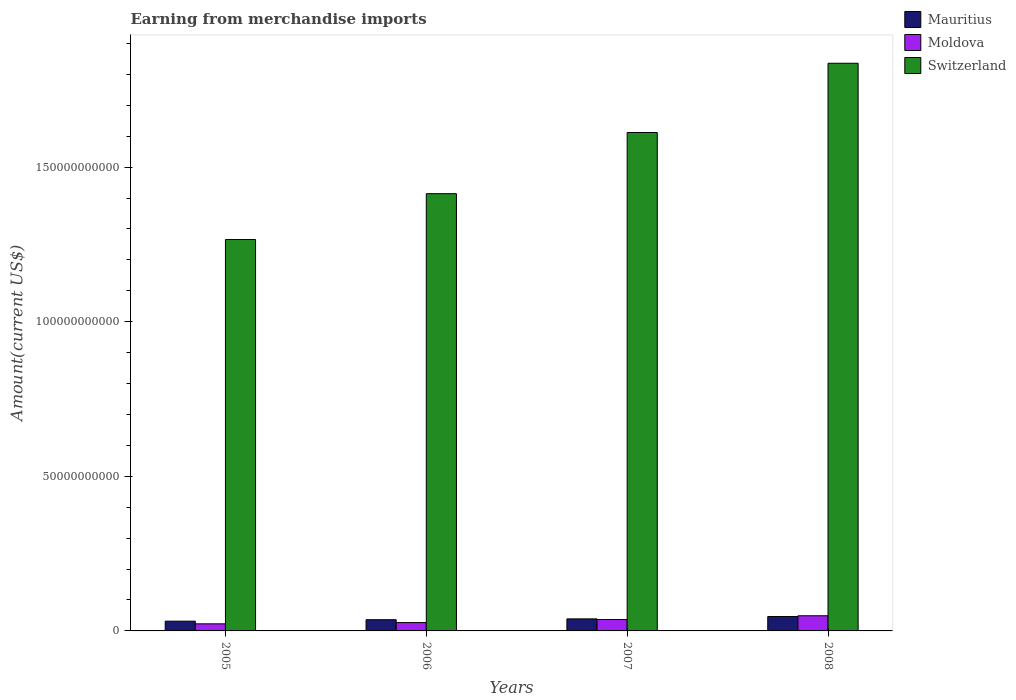How many different coloured bars are there?
Your response must be concise. 3. How many groups of bars are there?
Make the answer very short. 4. Are the number of bars per tick equal to the number of legend labels?
Offer a very short reply. Yes. How many bars are there on the 2nd tick from the left?
Provide a succinct answer. 3. How many bars are there on the 4th tick from the right?
Your answer should be very brief. 3. In how many cases, is the number of bars for a given year not equal to the number of legend labels?
Your response must be concise. 0. What is the amount earned from merchandise imports in Switzerland in 2005?
Give a very brief answer. 1.27e+11. Across all years, what is the maximum amount earned from merchandise imports in Moldova?
Your answer should be very brief. 4.90e+09. Across all years, what is the minimum amount earned from merchandise imports in Moldova?
Your answer should be compact. 2.29e+09. In which year was the amount earned from merchandise imports in Moldova minimum?
Your answer should be compact. 2005. What is the total amount earned from merchandise imports in Mauritius in the graph?
Your answer should be compact. 1.53e+1. What is the difference between the amount earned from merchandise imports in Mauritius in 2005 and that in 2006?
Your answer should be very brief. -4.70e+08. What is the difference between the amount earned from merchandise imports in Mauritius in 2008 and the amount earned from merchandise imports in Moldova in 2006?
Your answer should be compact. 1.96e+09. What is the average amount earned from merchandise imports in Mauritius per year?
Keep it short and to the point. 3.83e+09. In the year 2007, what is the difference between the amount earned from merchandise imports in Mauritius and amount earned from merchandise imports in Switzerland?
Ensure brevity in your answer.  -1.57e+11. In how many years, is the amount earned from merchandise imports in Switzerland greater than 170000000000 US$?
Offer a terse response. 1. What is the ratio of the amount earned from merchandise imports in Switzerland in 2006 to that in 2008?
Keep it short and to the point. 0.77. Is the amount earned from merchandise imports in Switzerland in 2005 less than that in 2008?
Make the answer very short. Yes. What is the difference between the highest and the second highest amount earned from merchandise imports in Switzerland?
Your answer should be very brief. 2.24e+1. What is the difference between the highest and the lowest amount earned from merchandise imports in Moldova?
Give a very brief answer. 2.61e+09. In how many years, is the amount earned from merchandise imports in Mauritius greater than the average amount earned from merchandise imports in Mauritius taken over all years?
Your response must be concise. 2. What does the 2nd bar from the left in 2007 represents?
Your response must be concise. Moldova. What does the 3rd bar from the right in 2007 represents?
Ensure brevity in your answer.  Mauritius. Are all the bars in the graph horizontal?
Provide a succinct answer. No. How many years are there in the graph?
Offer a very short reply. 4. What is the difference between two consecutive major ticks on the Y-axis?
Provide a succinct answer. 5.00e+1. Are the values on the major ticks of Y-axis written in scientific E-notation?
Offer a terse response. No. Does the graph contain any zero values?
Provide a short and direct response. No. What is the title of the graph?
Give a very brief answer. Earning from merchandise imports. Does "Eritrea" appear as one of the legend labels in the graph?
Your answer should be very brief. No. What is the label or title of the Y-axis?
Keep it short and to the point. Amount(current US$). What is the Amount(current US$) of Mauritius in 2005?
Ensure brevity in your answer.  3.16e+09. What is the Amount(current US$) in Moldova in 2005?
Your answer should be compact. 2.29e+09. What is the Amount(current US$) in Switzerland in 2005?
Your response must be concise. 1.27e+11. What is the Amount(current US$) in Mauritius in 2006?
Ensure brevity in your answer.  3.63e+09. What is the Amount(current US$) of Moldova in 2006?
Make the answer very short. 2.69e+09. What is the Amount(current US$) of Switzerland in 2006?
Give a very brief answer. 1.41e+11. What is the Amount(current US$) of Mauritius in 2007?
Give a very brief answer. 3.89e+09. What is the Amount(current US$) of Moldova in 2007?
Offer a very short reply. 3.69e+09. What is the Amount(current US$) in Switzerland in 2007?
Give a very brief answer. 1.61e+11. What is the Amount(current US$) in Mauritius in 2008?
Your response must be concise. 4.65e+09. What is the Amount(current US$) in Moldova in 2008?
Your response must be concise. 4.90e+09. What is the Amount(current US$) of Switzerland in 2008?
Ensure brevity in your answer.  1.84e+11. Across all years, what is the maximum Amount(current US$) in Mauritius?
Make the answer very short. 4.65e+09. Across all years, what is the maximum Amount(current US$) of Moldova?
Offer a very short reply. 4.90e+09. Across all years, what is the maximum Amount(current US$) of Switzerland?
Ensure brevity in your answer.  1.84e+11. Across all years, what is the minimum Amount(current US$) in Mauritius?
Offer a very short reply. 3.16e+09. Across all years, what is the minimum Amount(current US$) of Moldova?
Your answer should be compact. 2.29e+09. Across all years, what is the minimum Amount(current US$) of Switzerland?
Keep it short and to the point. 1.27e+11. What is the total Amount(current US$) of Mauritius in the graph?
Provide a succinct answer. 1.53e+1. What is the total Amount(current US$) of Moldova in the graph?
Keep it short and to the point. 1.36e+1. What is the total Amount(current US$) of Switzerland in the graph?
Provide a succinct answer. 6.13e+11. What is the difference between the Amount(current US$) in Mauritius in 2005 and that in 2006?
Provide a succinct answer. -4.70e+08. What is the difference between the Amount(current US$) in Moldova in 2005 and that in 2006?
Keep it short and to the point. -4.01e+08. What is the difference between the Amount(current US$) of Switzerland in 2005 and that in 2006?
Offer a terse response. -1.48e+1. What is the difference between the Amount(current US$) of Mauritius in 2005 and that in 2007?
Your answer should be compact. -7.37e+08. What is the difference between the Amount(current US$) in Moldova in 2005 and that in 2007?
Make the answer very short. -1.40e+09. What is the difference between the Amount(current US$) of Switzerland in 2005 and that in 2007?
Ensure brevity in your answer.  -3.46e+1. What is the difference between the Amount(current US$) in Mauritius in 2005 and that in 2008?
Make the answer very short. -1.49e+09. What is the difference between the Amount(current US$) of Moldova in 2005 and that in 2008?
Provide a succinct answer. -2.61e+09. What is the difference between the Amount(current US$) in Switzerland in 2005 and that in 2008?
Your answer should be compact. -5.70e+1. What is the difference between the Amount(current US$) in Mauritius in 2006 and that in 2007?
Give a very brief answer. -2.67e+08. What is the difference between the Amount(current US$) of Moldova in 2006 and that in 2007?
Ensure brevity in your answer.  -9.97e+08. What is the difference between the Amount(current US$) in Switzerland in 2006 and that in 2007?
Ensure brevity in your answer.  -1.98e+1. What is the difference between the Amount(current US$) of Mauritius in 2006 and that in 2008?
Ensure brevity in your answer.  -1.02e+09. What is the difference between the Amount(current US$) in Moldova in 2006 and that in 2008?
Offer a very short reply. -2.21e+09. What is the difference between the Amount(current US$) in Switzerland in 2006 and that in 2008?
Give a very brief answer. -4.22e+1. What is the difference between the Amount(current US$) of Mauritius in 2007 and that in 2008?
Ensure brevity in your answer.  -7.58e+08. What is the difference between the Amount(current US$) in Moldova in 2007 and that in 2008?
Give a very brief answer. -1.21e+09. What is the difference between the Amount(current US$) of Switzerland in 2007 and that in 2008?
Offer a very short reply. -2.24e+1. What is the difference between the Amount(current US$) of Mauritius in 2005 and the Amount(current US$) of Moldova in 2006?
Your answer should be very brief. 4.64e+08. What is the difference between the Amount(current US$) of Mauritius in 2005 and the Amount(current US$) of Switzerland in 2006?
Provide a succinct answer. -1.38e+11. What is the difference between the Amount(current US$) of Moldova in 2005 and the Amount(current US$) of Switzerland in 2006?
Your response must be concise. -1.39e+11. What is the difference between the Amount(current US$) in Mauritius in 2005 and the Amount(current US$) in Moldova in 2007?
Offer a very short reply. -5.33e+08. What is the difference between the Amount(current US$) in Mauritius in 2005 and the Amount(current US$) in Switzerland in 2007?
Make the answer very short. -1.58e+11. What is the difference between the Amount(current US$) in Moldova in 2005 and the Amount(current US$) in Switzerland in 2007?
Offer a terse response. -1.59e+11. What is the difference between the Amount(current US$) in Mauritius in 2005 and the Amount(current US$) in Moldova in 2008?
Provide a succinct answer. -1.74e+09. What is the difference between the Amount(current US$) of Mauritius in 2005 and the Amount(current US$) of Switzerland in 2008?
Your response must be concise. -1.80e+11. What is the difference between the Amount(current US$) of Moldova in 2005 and the Amount(current US$) of Switzerland in 2008?
Your answer should be compact. -1.81e+11. What is the difference between the Amount(current US$) in Mauritius in 2006 and the Amount(current US$) in Moldova in 2007?
Make the answer very short. -6.31e+07. What is the difference between the Amount(current US$) in Mauritius in 2006 and the Amount(current US$) in Switzerland in 2007?
Your answer should be compact. -1.58e+11. What is the difference between the Amount(current US$) in Moldova in 2006 and the Amount(current US$) in Switzerland in 2007?
Your response must be concise. -1.58e+11. What is the difference between the Amount(current US$) in Mauritius in 2006 and the Amount(current US$) in Moldova in 2008?
Keep it short and to the point. -1.27e+09. What is the difference between the Amount(current US$) in Mauritius in 2006 and the Amount(current US$) in Switzerland in 2008?
Make the answer very short. -1.80e+11. What is the difference between the Amount(current US$) of Moldova in 2006 and the Amount(current US$) of Switzerland in 2008?
Offer a terse response. -1.81e+11. What is the difference between the Amount(current US$) of Mauritius in 2007 and the Amount(current US$) of Moldova in 2008?
Keep it short and to the point. -1.01e+09. What is the difference between the Amount(current US$) of Mauritius in 2007 and the Amount(current US$) of Switzerland in 2008?
Keep it short and to the point. -1.80e+11. What is the difference between the Amount(current US$) of Moldova in 2007 and the Amount(current US$) of Switzerland in 2008?
Offer a terse response. -1.80e+11. What is the average Amount(current US$) in Mauritius per year?
Provide a succinct answer. 3.83e+09. What is the average Amount(current US$) in Moldova per year?
Your answer should be compact. 3.39e+09. What is the average Amount(current US$) in Switzerland per year?
Ensure brevity in your answer.  1.53e+11. In the year 2005, what is the difference between the Amount(current US$) in Mauritius and Amount(current US$) in Moldova?
Ensure brevity in your answer.  8.65e+08. In the year 2005, what is the difference between the Amount(current US$) of Mauritius and Amount(current US$) of Switzerland?
Make the answer very short. -1.23e+11. In the year 2005, what is the difference between the Amount(current US$) in Moldova and Amount(current US$) in Switzerland?
Your answer should be compact. -1.24e+11. In the year 2006, what is the difference between the Amount(current US$) of Mauritius and Amount(current US$) of Moldova?
Your response must be concise. 9.34e+08. In the year 2006, what is the difference between the Amount(current US$) of Mauritius and Amount(current US$) of Switzerland?
Keep it short and to the point. -1.38e+11. In the year 2006, what is the difference between the Amount(current US$) in Moldova and Amount(current US$) in Switzerland?
Give a very brief answer. -1.39e+11. In the year 2007, what is the difference between the Amount(current US$) of Mauritius and Amount(current US$) of Moldova?
Offer a terse response. 2.04e+08. In the year 2007, what is the difference between the Amount(current US$) in Mauritius and Amount(current US$) in Switzerland?
Give a very brief answer. -1.57e+11. In the year 2007, what is the difference between the Amount(current US$) of Moldova and Amount(current US$) of Switzerland?
Keep it short and to the point. -1.57e+11. In the year 2008, what is the difference between the Amount(current US$) of Mauritius and Amount(current US$) of Moldova?
Provide a succinct answer. -2.47e+08. In the year 2008, what is the difference between the Amount(current US$) in Mauritius and Amount(current US$) in Switzerland?
Your answer should be compact. -1.79e+11. In the year 2008, what is the difference between the Amount(current US$) of Moldova and Amount(current US$) of Switzerland?
Make the answer very short. -1.79e+11. What is the ratio of the Amount(current US$) in Mauritius in 2005 to that in 2006?
Offer a terse response. 0.87. What is the ratio of the Amount(current US$) of Moldova in 2005 to that in 2006?
Your answer should be compact. 0.85. What is the ratio of the Amount(current US$) in Switzerland in 2005 to that in 2006?
Make the answer very short. 0.9. What is the ratio of the Amount(current US$) of Mauritius in 2005 to that in 2007?
Your answer should be very brief. 0.81. What is the ratio of the Amount(current US$) of Moldova in 2005 to that in 2007?
Offer a terse response. 0.62. What is the ratio of the Amount(current US$) of Switzerland in 2005 to that in 2007?
Keep it short and to the point. 0.79. What is the ratio of the Amount(current US$) in Mauritius in 2005 to that in 2008?
Keep it short and to the point. 0.68. What is the ratio of the Amount(current US$) of Moldova in 2005 to that in 2008?
Your response must be concise. 0.47. What is the ratio of the Amount(current US$) of Switzerland in 2005 to that in 2008?
Provide a short and direct response. 0.69. What is the ratio of the Amount(current US$) of Mauritius in 2006 to that in 2007?
Provide a succinct answer. 0.93. What is the ratio of the Amount(current US$) in Moldova in 2006 to that in 2007?
Your response must be concise. 0.73. What is the ratio of the Amount(current US$) in Switzerland in 2006 to that in 2007?
Your response must be concise. 0.88. What is the ratio of the Amount(current US$) in Mauritius in 2006 to that in 2008?
Your response must be concise. 0.78. What is the ratio of the Amount(current US$) of Moldova in 2006 to that in 2008?
Offer a terse response. 0.55. What is the ratio of the Amount(current US$) in Switzerland in 2006 to that in 2008?
Give a very brief answer. 0.77. What is the ratio of the Amount(current US$) of Mauritius in 2007 to that in 2008?
Keep it short and to the point. 0.84. What is the ratio of the Amount(current US$) in Moldova in 2007 to that in 2008?
Offer a terse response. 0.75. What is the ratio of the Amount(current US$) in Switzerland in 2007 to that in 2008?
Make the answer very short. 0.88. What is the difference between the highest and the second highest Amount(current US$) of Mauritius?
Provide a succinct answer. 7.58e+08. What is the difference between the highest and the second highest Amount(current US$) in Moldova?
Provide a short and direct response. 1.21e+09. What is the difference between the highest and the second highest Amount(current US$) in Switzerland?
Your answer should be very brief. 2.24e+1. What is the difference between the highest and the lowest Amount(current US$) in Mauritius?
Ensure brevity in your answer.  1.49e+09. What is the difference between the highest and the lowest Amount(current US$) of Moldova?
Your answer should be compact. 2.61e+09. What is the difference between the highest and the lowest Amount(current US$) of Switzerland?
Provide a succinct answer. 5.70e+1. 